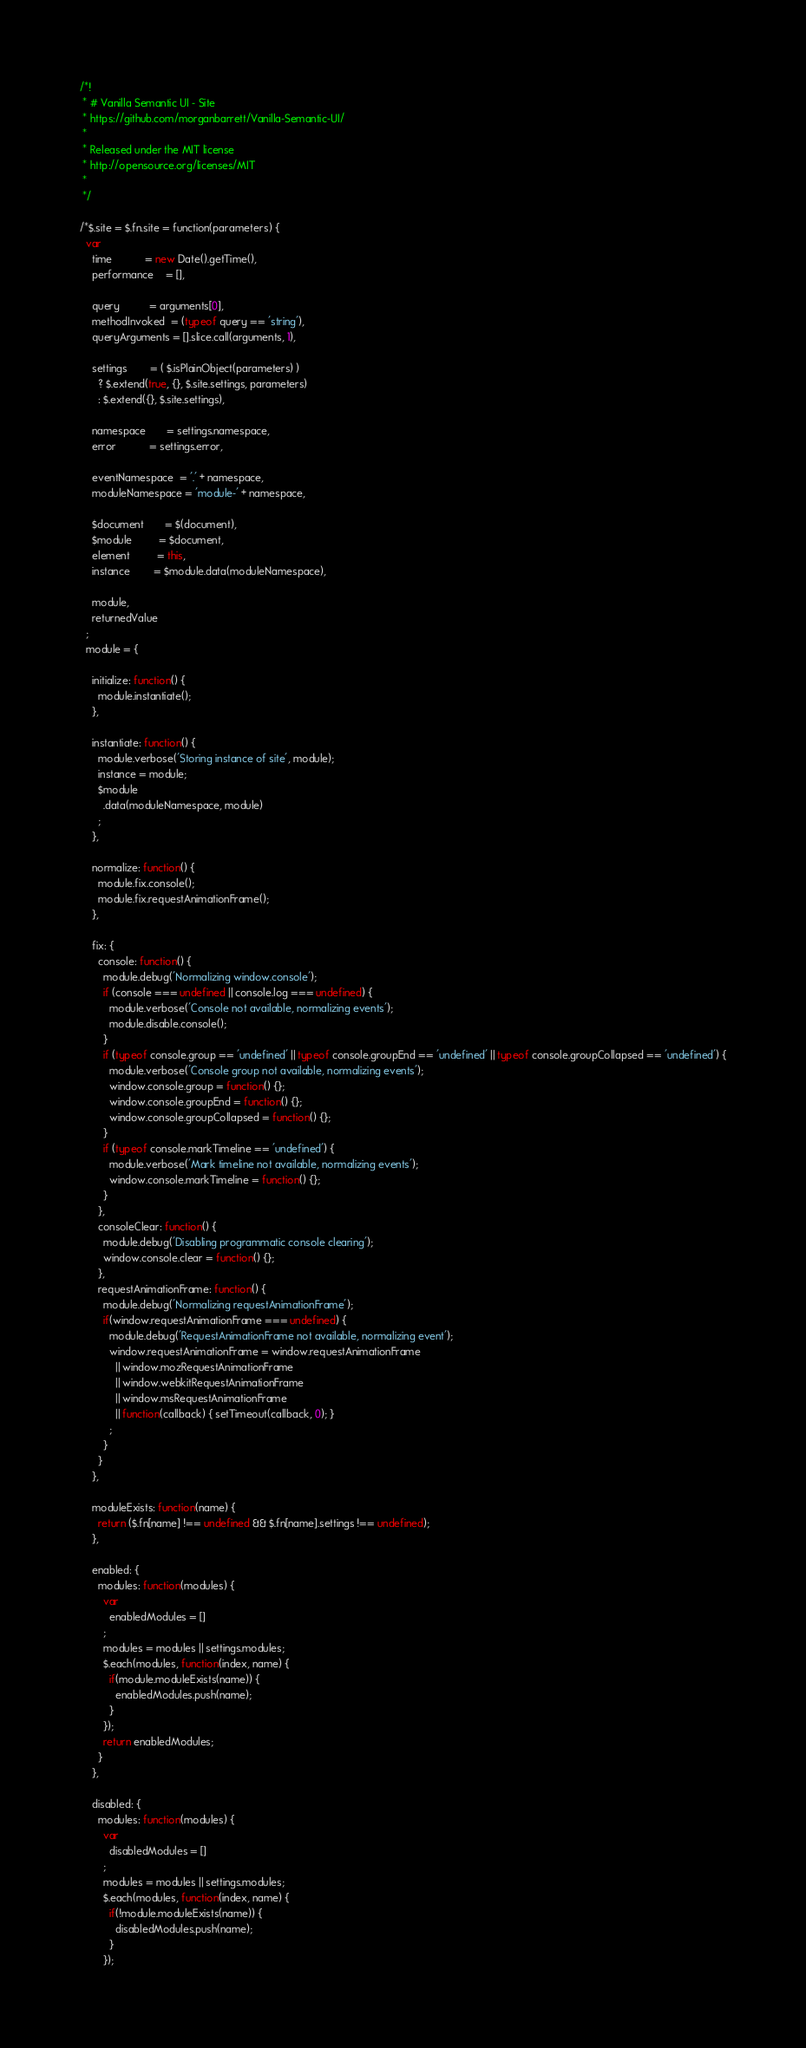<code> <loc_0><loc_0><loc_500><loc_500><_JavaScript_>/*!
 * # Vanilla Semantic UI - Site
 * https://github.com/morganbarrett/Vanilla-Semantic-UI/
 *
 * Released under the MIT license
 * http://opensource.org/licenses/MIT
 *
 */

/*$.site = $.fn.site = function(parameters) {
  var
    time           = new Date().getTime(),
    performance    = [],

    query          = arguments[0],
    methodInvoked  = (typeof query == 'string'),
    queryArguments = [].slice.call(arguments, 1),

    settings        = ( $.isPlainObject(parameters) )
      ? $.extend(true, {}, $.site.settings, parameters)
      : $.extend({}, $.site.settings),

    namespace       = settings.namespace,
    error           = settings.error,

    eventNamespace  = '.' + namespace,
    moduleNamespace = 'module-' + namespace,

    $document       = $(document),
    $module         = $document,
    element         = this,
    instance        = $module.data(moduleNamespace),

    module,
    returnedValue
  ;
  module = {

    initialize: function() {
      module.instantiate();
    },

    instantiate: function() {
      module.verbose('Storing instance of site', module);
      instance = module;
      $module
        .data(moduleNamespace, module)
      ;
    },

    normalize: function() {
      module.fix.console();
      module.fix.requestAnimationFrame();
    },

    fix: {
      console: function() {
        module.debug('Normalizing window.console');
        if (console === undefined || console.log === undefined) {
          module.verbose('Console not available, normalizing events');
          module.disable.console();
        }
        if (typeof console.group == 'undefined' || typeof console.groupEnd == 'undefined' || typeof console.groupCollapsed == 'undefined') {
          module.verbose('Console group not available, normalizing events');
          window.console.group = function() {};
          window.console.groupEnd = function() {};
          window.console.groupCollapsed = function() {};
        }
        if (typeof console.markTimeline == 'undefined') {
          module.verbose('Mark timeline not available, normalizing events');
          window.console.markTimeline = function() {};
        }
      },
      consoleClear: function() {
        module.debug('Disabling programmatic console clearing');
        window.console.clear = function() {};
      },
      requestAnimationFrame: function() {
        module.debug('Normalizing requestAnimationFrame');
        if(window.requestAnimationFrame === undefined) {
          module.debug('RequestAnimationFrame not available, normalizing event');
          window.requestAnimationFrame = window.requestAnimationFrame
            || window.mozRequestAnimationFrame
            || window.webkitRequestAnimationFrame
            || window.msRequestAnimationFrame
            || function(callback) { setTimeout(callback, 0); }
          ;
        }
      }
    },

    moduleExists: function(name) {
      return ($.fn[name] !== undefined && $.fn[name].settings !== undefined);
    },

    enabled: {
      modules: function(modules) {
        var
          enabledModules = []
        ;
        modules = modules || settings.modules;
        $.each(modules, function(index, name) {
          if(module.moduleExists(name)) {
            enabledModules.push(name);
          }
        });
        return enabledModules;
      }
    },

    disabled: {
      modules: function(modules) {
        var
          disabledModules = []
        ;
        modules = modules || settings.modules;
        $.each(modules, function(index, name) {
          if(!module.moduleExists(name)) {
            disabledModules.push(name);
          }
        });</code> 